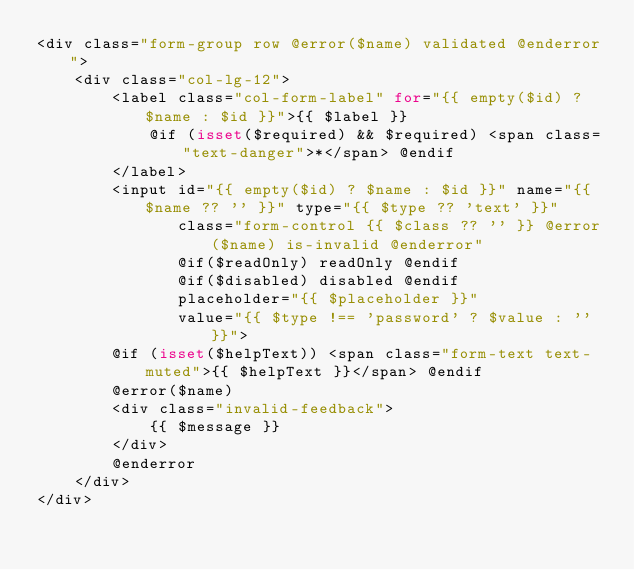Convert code to text. <code><loc_0><loc_0><loc_500><loc_500><_PHP_><div class="form-group row @error($name) validated @enderror">
    <div class="col-lg-12">
        <label class="col-form-label" for="{{ empty($id) ? $name : $id }}">{{ $label }}
            @if (isset($required) && $required) <span class="text-danger">*</span> @endif
        </label>
        <input id="{{ empty($id) ? $name : $id }}" name="{{ $name ?? '' }}" type="{{ $type ?? 'text' }}"
               class="form-control {{ $class ?? '' }} @error($name) is-invalid @enderror"
               @if($readOnly) readOnly @endif
               @if($disabled) disabled @endif
               placeholder="{{ $placeholder }}"
               value="{{ $type !== 'password' ? $value : '' }}">
        @if (isset($helpText)) <span class="form-text text-muted">{{ $helpText }}</span> @endif
        @error($name)
        <div class="invalid-feedback">
            {{ $message }}
        </div>
        @enderror
    </div>
</div>
</code> 